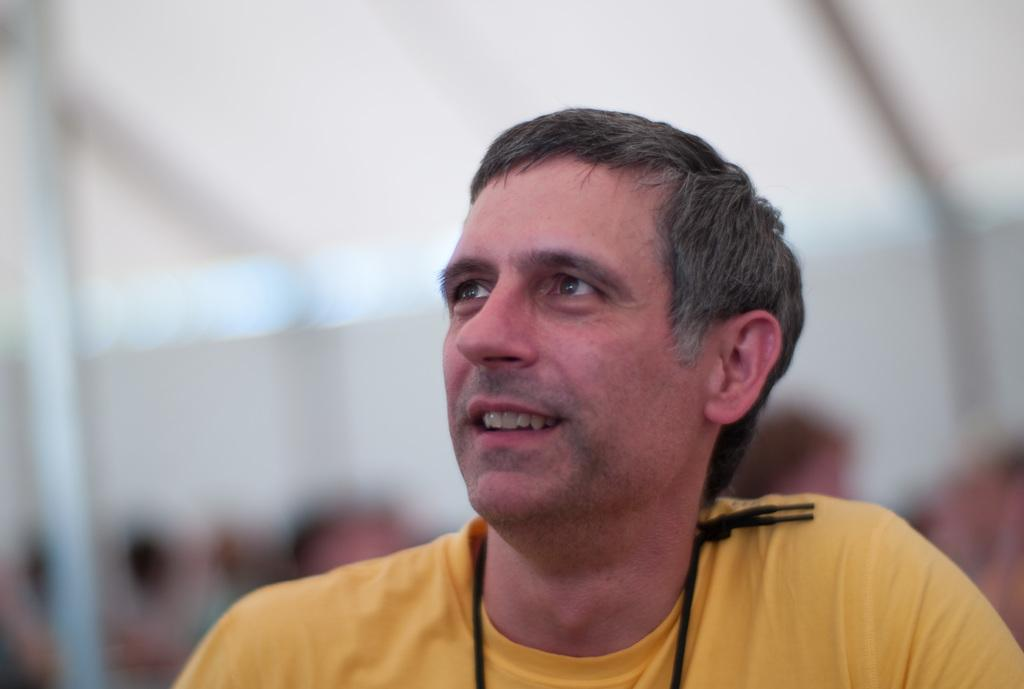Who is the main subject in the image? There is a person in the image. Where is the person located in relation to the other people? The person is in front. Can you describe the people behind the person? There are a few other people behind the person. What is the condition of the background in the image? The background of the image is blurred. What type of vessel is being used to transport the quince in the image? There is no vessel or quince present in the image. 